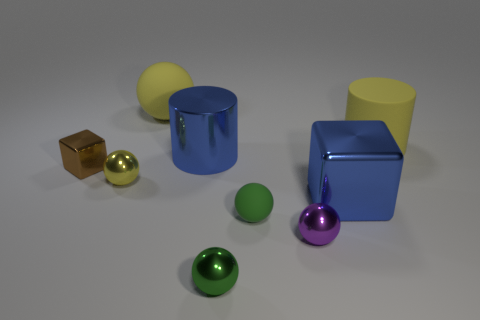Subtract all tiny green matte spheres. How many spheres are left? 4 Add 1 brown matte cylinders. How many objects exist? 10 Subtract all purple spheres. How many spheres are left? 4 Subtract all balls. How many objects are left? 4 Subtract 3 spheres. How many spheres are left? 2 Subtract all brown cylinders. How many blue cubes are left? 1 Subtract 0 cyan balls. How many objects are left? 9 Subtract all gray cylinders. Subtract all green balls. How many cylinders are left? 2 Subtract all large yellow metallic objects. Subtract all large cylinders. How many objects are left? 7 Add 9 green metal spheres. How many green metal spheres are left? 10 